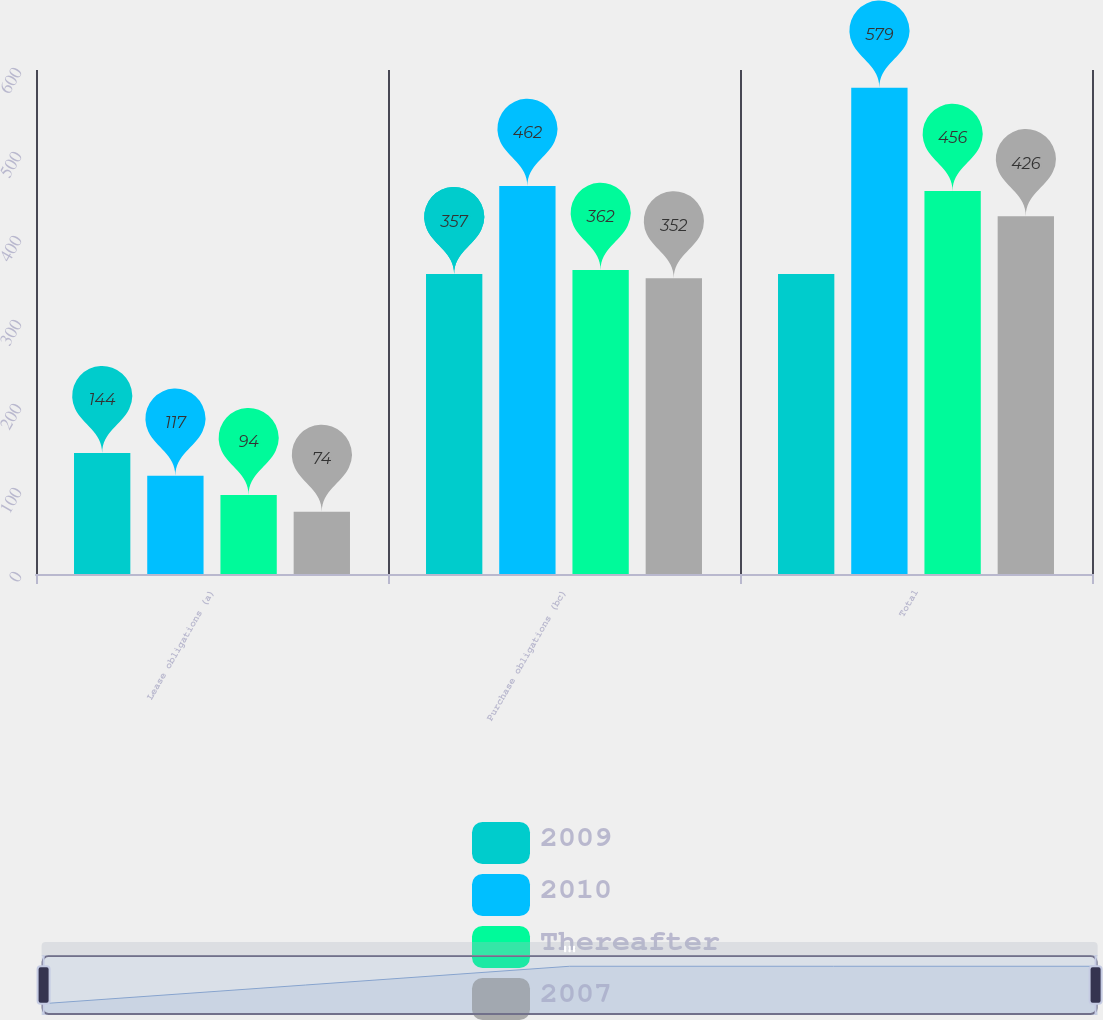Convert chart. <chart><loc_0><loc_0><loc_500><loc_500><stacked_bar_chart><ecel><fcel>Lease obligations (a)<fcel>Purchase obligations (bc)<fcel>Total<nl><fcel>2009<fcel>144<fcel>357<fcel>357<nl><fcel>2010<fcel>117<fcel>462<fcel>579<nl><fcel>Thereafter<fcel>94<fcel>362<fcel>456<nl><fcel>2007<fcel>74<fcel>352<fcel>426<nl></chart> 